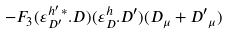Convert formula to latex. <formula><loc_0><loc_0><loc_500><loc_500>- F _ { 3 } ( \varepsilon _ { D ^ { \prime } } ^ { h ^ { \prime } \, \ast } . D ) ( \varepsilon _ { D } ^ { h } . D ^ { \prime } ) ( D _ { \mu } + { D ^ { \prime } } _ { \mu } )</formula> 